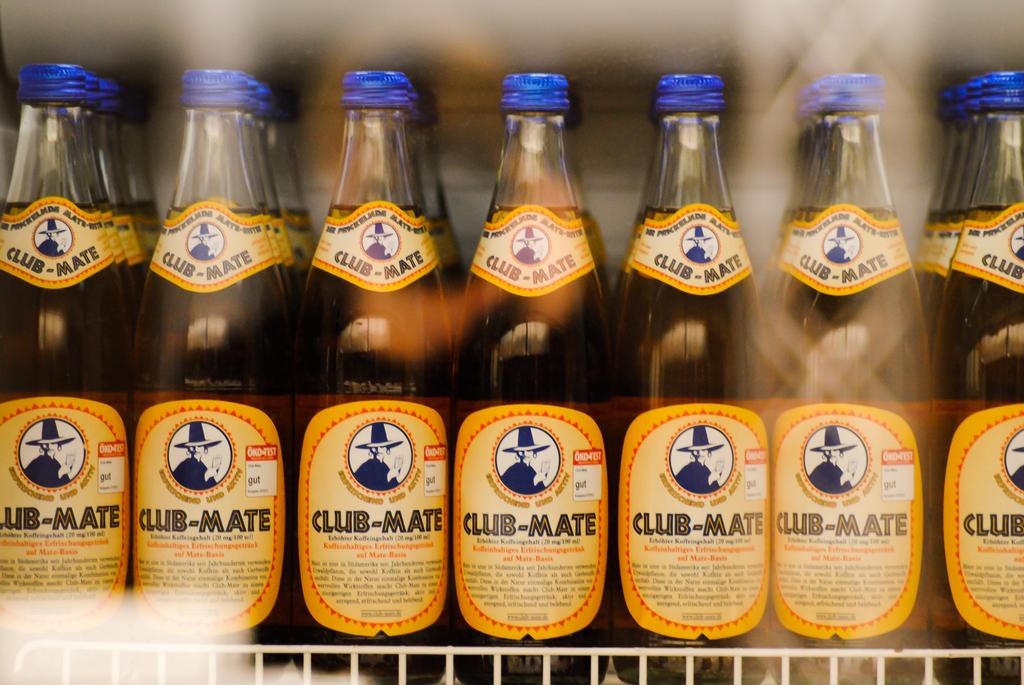What brand of drink is shown here?
Offer a very short reply. Club-mate. What 3 letter word is written on the white sticker?
Provide a succinct answer. Gut. 